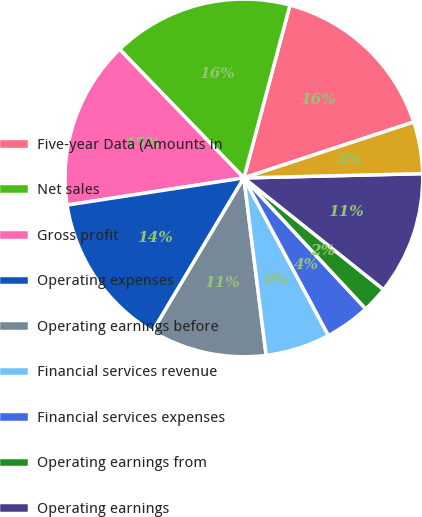<chart> <loc_0><loc_0><loc_500><loc_500><pie_chart><fcel>Five-year Data (Amounts in<fcel>Net sales<fcel>Gross profit<fcel>Operating expenses<fcel>Operating earnings before<fcel>Financial services revenue<fcel>Financial services expenses<fcel>Operating earnings from<fcel>Operating earnings<fcel>Interest expense<nl><fcel>15.79%<fcel>16.37%<fcel>15.2%<fcel>14.03%<fcel>10.53%<fcel>5.85%<fcel>4.09%<fcel>2.34%<fcel>11.11%<fcel>4.68%<nl></chart> 